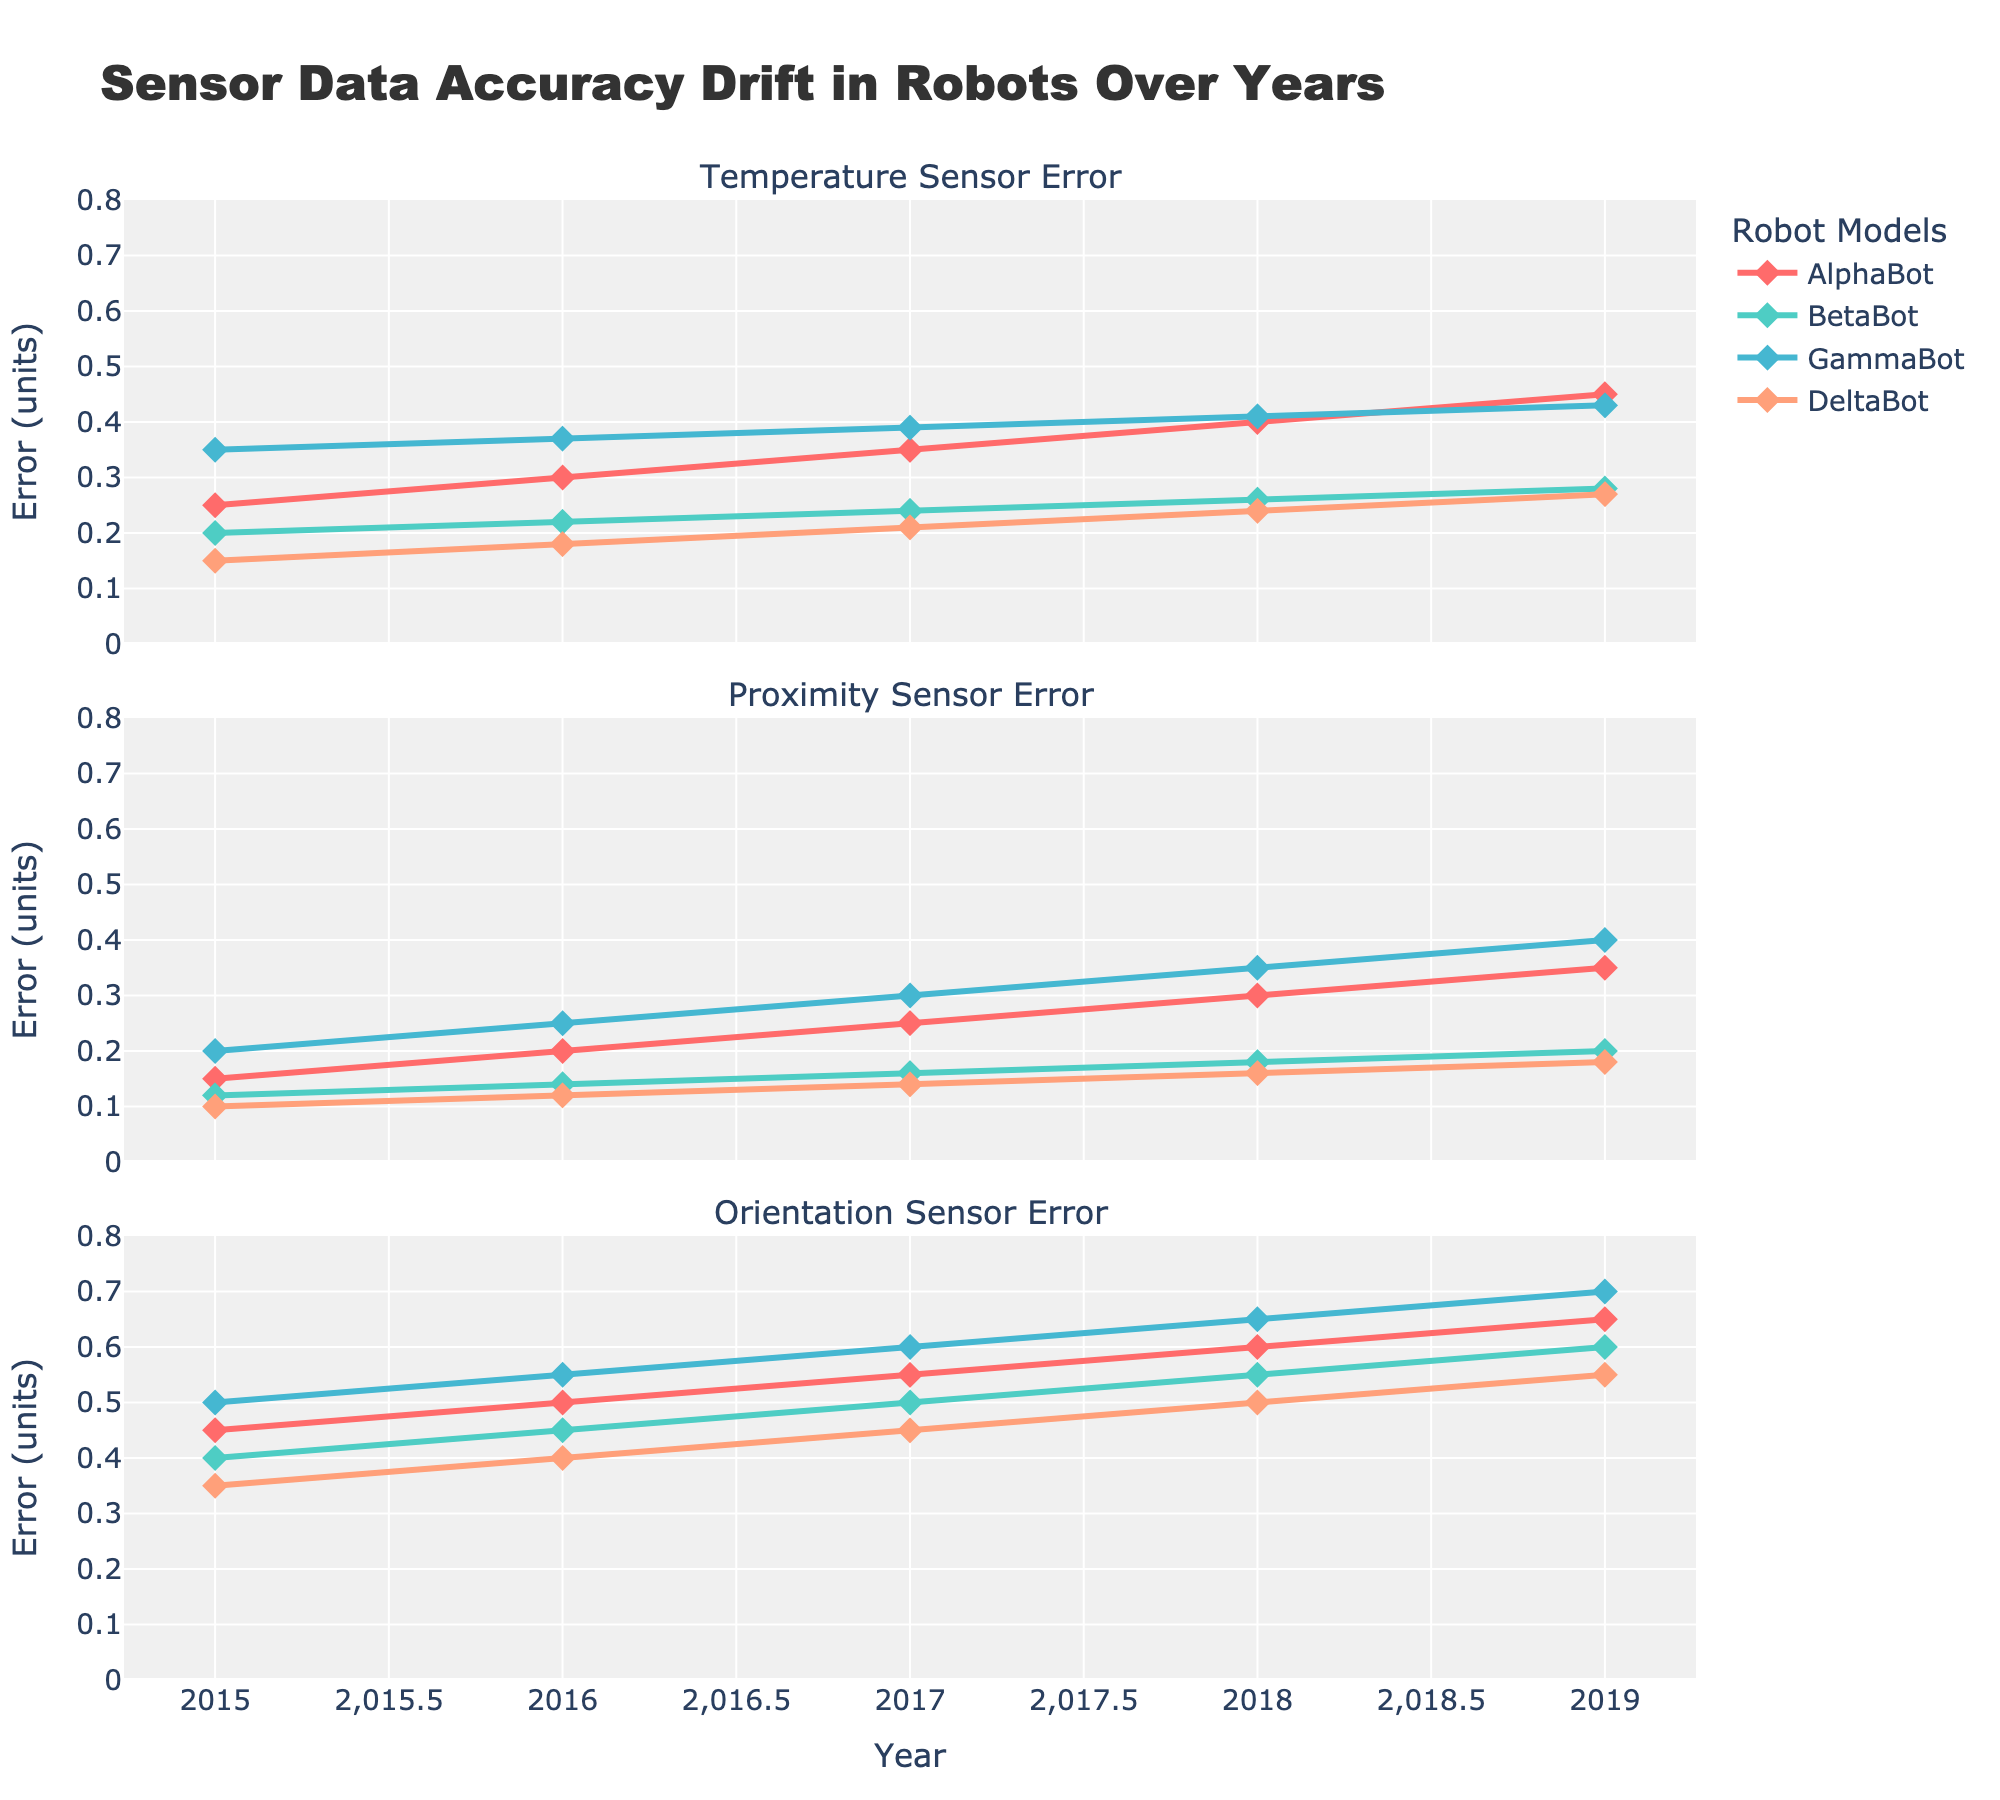What is the general trend in the Temperature Sensor Error for AlphaBot from 2015 to 2019? The figure shows a line plot where the Temperature Sensor Error for AlphaBot increases steadily every year from 0.25 in 2015 to 0.45 in 2019.
Answer: Increasing Which robot model had the lowest Proximity Sensor Error in 2015? By examining the first sub-plot titled "Proximity Sensor Error," you can observe that in 2015, DeltaBot had the lowest error at 0.10.
Answer: DeltaBot How does the Proximity Sensor Error for GammaBot compare in 2016 and 2019? The graph shows that the Proximity Sensor Error for GammaBot increased from 0.25 in 2016 to 0.40 in 2019.
Answer: Increased What is the mean Orientation Sensor Error for BetaBot over the five-year period? The Orientation Sensor Errors for BetaBot from 2015 to 2019 are 0.40, 0.45, 0.50, 0.55, and 0.60. Adding these values gives 2.50. Dividing by 5, the mean error is 2.50/5 = 0.50.
Answer: 0.50 Which robot had the highest Temperature Sensor Error in 2017? Referring to the "Temperature Sensor Error" subplot, GammaBot has the highest Temperature Sensor Error in 2017 at 0.39.
Answer: GammaBot What is the difference between the Proximity Sensor Error of AlphaBot and DeltaBot in 2019? In 2019, AlphaBot has a Proximity Sensor Error of 0.35, and DeltaBot has an error of 0.18. The difference is 0.35 - 0.18 = 0.17.
Answer: 0.17 In which year did BetaBot experience an increase in Temperature Sensor Error? The line plot for BetaBot in the "Temperature Sensor Error" subplot shows an increase in error every year from 2016 to 2019.
Answer: Every year Which robot model had the least increase in Orientation Sensor Error from 2015 to 2019? DeltaBot showed a rise from 0.35 in 2015 to 0.55 in 2019. Calculate change: 0.55 - 0.35 = 0.20. Comparing increases for all models show that DeltaBot had the least increase.
Answer: DeltaBot Is AlphaBot's Proximity Sensor Error in 2016 higher or lower than its Orientation Sensor Error in the same year? In 2016, AlphaBot's Proximity Sensor Error is 0.20, while its Orientation Sensor Error is 0.50. Comparatively, 0.20 is lower than 0.50.
Answer: Lower 